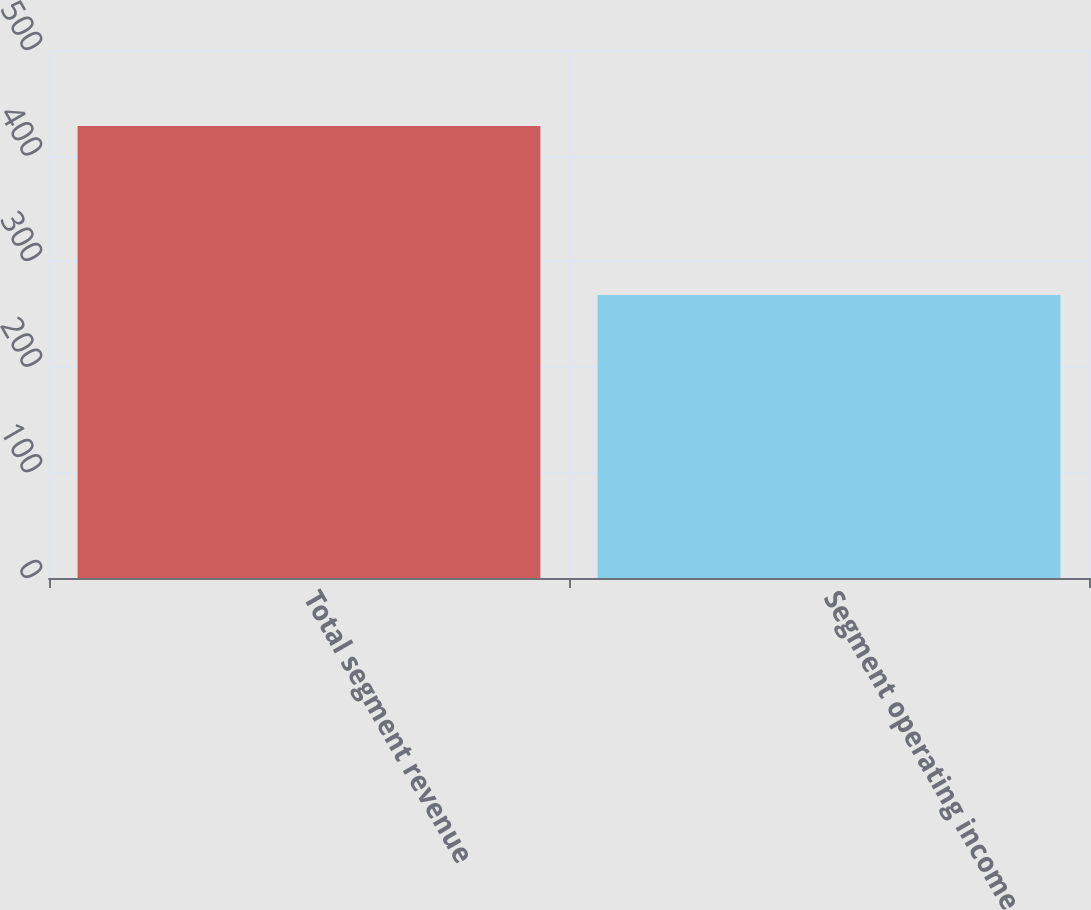<chart> <loc_0><loc_0><loc_500><loc_500><bar_chart><fcel>Total segment revenue<fcel>Segment operating income<nl><fcel>428<fcel>268<nl></chart> 